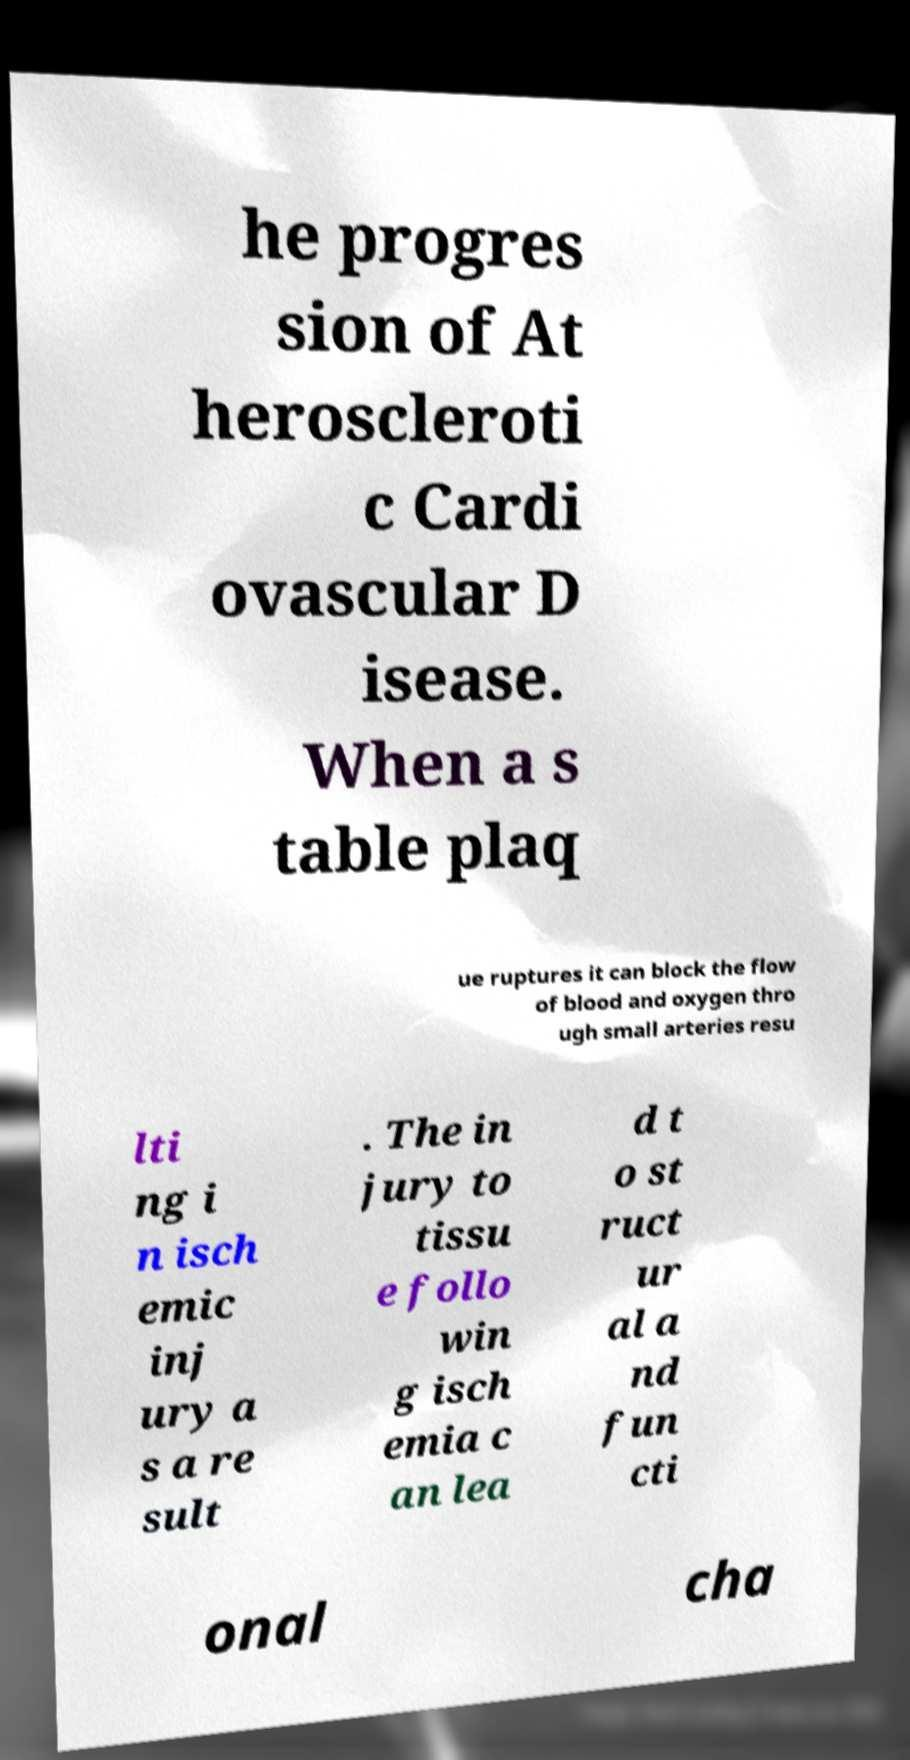What messages or text are displayed in this image? I need them in a readable, typed format. he progres sion of At heroscleroti c Cardi ovascular D isease. When a s table plaq ue ruptures it can block the flow of blood and oxygen thro ugh small arteries resu lti ng i n isch emic inj ury a s a re sult . The in jury to tissu e follo win g isch emia c an lea d t o st ruct ur al a nd fun cti onal cha 